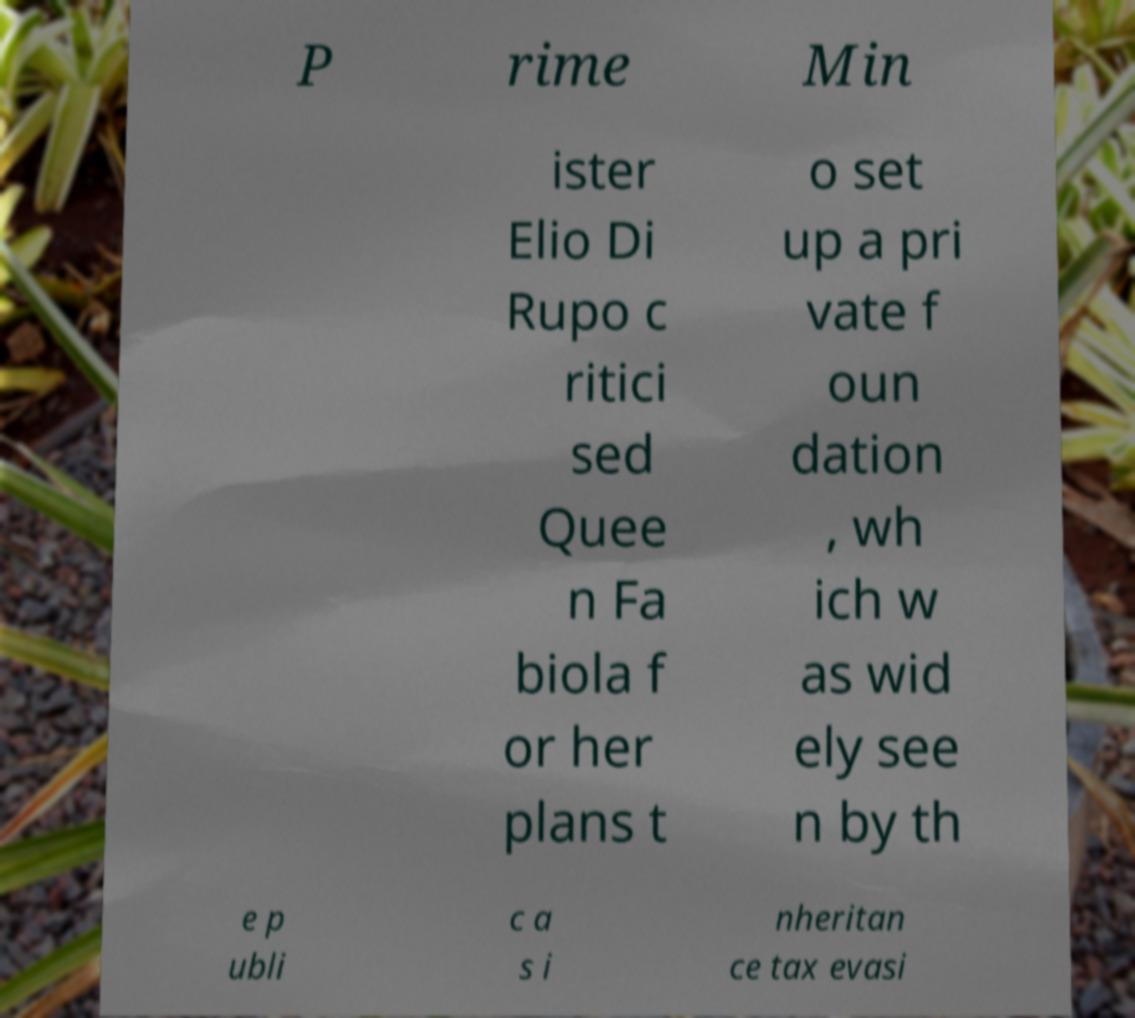There's text embedded in this image that I need extracted. Can you transcribe it verbatim? P rime Min ister Elio Di Rupo c ritici sed Quee n Fa biola f or her plans t o set up a pri vate f oun dation , wh ich w as wid ely see n by th e p ubli c a s i nheritan ce tax evasi 